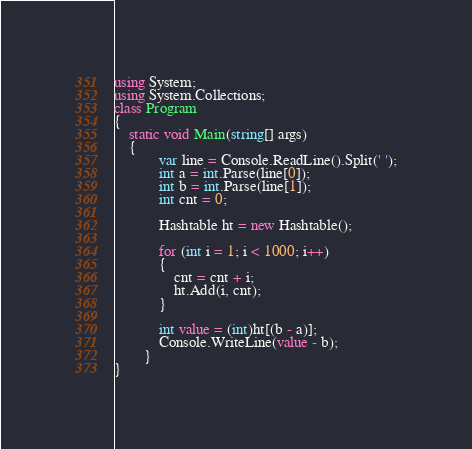Convert code to text. <code><loc_0><loc_0><loc_500><loc_500><_C#_>using System;
using System.Collections;
class Program
{
	static void Main(string[] args)
	{
            var line = Console.ReadLine().Split(' ');
            int a = int.Parse(line[0]);
            int b = int.Parse(line[1]);
            int cnt = 0;

            Hashtable ht = new Hashtable();

            for (int i = 1; i < 1000; i++)
            {
                cnt = cnt + i;
                ht.Add(i, cnt);
            }

            int value = (int)ht[(b - a)];
            Console.WriteLine(value - b);
        }
}</code> 